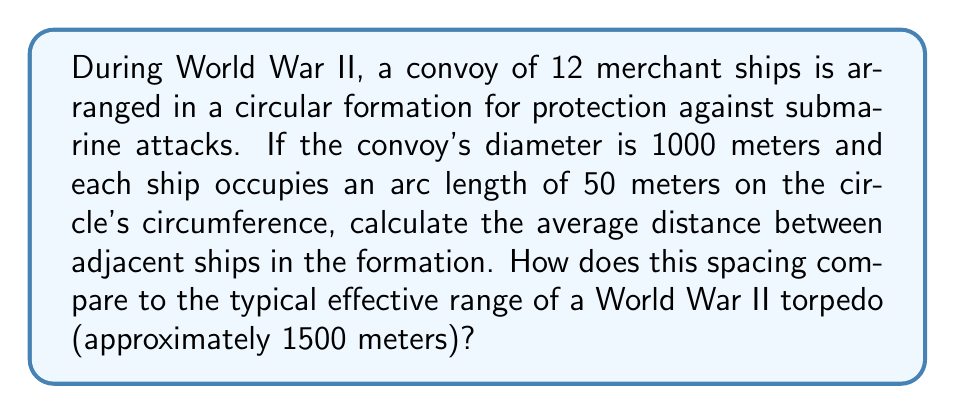What is the answer to this math problem? To solve this problem, we'll use geometric principles related to circles:

1. Calculate the circumference of the convoy formation:
   $$C = \pi d = \pi \cdot 1000 = 3141.59 \text{ meters}$$

2. Calculate the total arc length occupied by ships:
   $$\text{Total occupied arc} = 12 \text{ ships} \cdot 50 \text{ meters} = 600 \text{ meters}$$

3. Calculate the total unoccupied arc length:
   $$\text{Unoccupied arc} = 3141.59 - 600 = 2541.59 \text{ meters}$$

4. Calculate the average distance between ships:
   $$\text{Average distance} = \frac{2541.59 \text{ meters}}{12 \text{ gaps}} = 211.80 \text{ meters}$$

5. Compare to torpedo range:
   $$\text{Ratio} = \frac{211.80 \text{ meters}}{1500 \text{ meters}} \approx 0.1412 \text{ or } 14.12\%$$

This spacing is significantly smaller than the typical effective range of a World War II torpedo, which means the convoy formation is tightly packed for mutual protection.

[asy]
unitsize(0.2cm);
pair center = (0,0);
real r = 25;
draw(circle(center, r));
for(int i = 0; i < 12; ++i) {
  real angle = 2*pi*i/12;
  dot(center + r*expi(angle));
}
label("1000m", (r+2,0));
[/asy]
Answer: The average distance between adjacent ships is 211.80 meters, which is approximately 14.12% of the typical effective range of a World War II torpedo (1500 meters). 